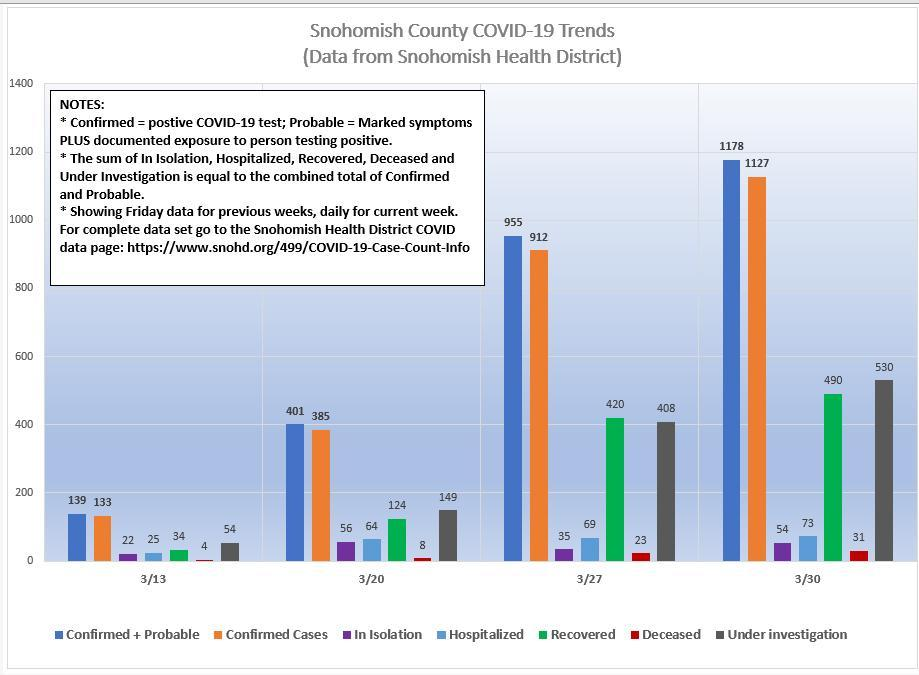What is the numbers of confirmed cases on 3/20?
Answer the question with a short phrase. 385 What is the numbers of people in isolation on 3/13? 22 What is the numbers of recovered cases on 3/27? 420 When was the number of people in isolation were the highest? 3/20 When was the number of hospitalized cases were the lowest? 3/13 When was the number of confirmed cases were the highest? 3/30 What is the numbers of recovered cases on 3/13? 34 When was the number of recovered cases were the highest? 3/30 On which day the number of people under investigation crossed 500? 3/30 What is the numbers of confirmed cases on 3/27? 912 What is the number of people under investigation on 3/13? 54 What is the number of people under investigation on 3/27? 408 On which day the number of confirmed cases crossed 1000? 3/30 When was the number of deceased were the lowest? 3/13 When was the number of confirmed cases were the lowest? 3/13 